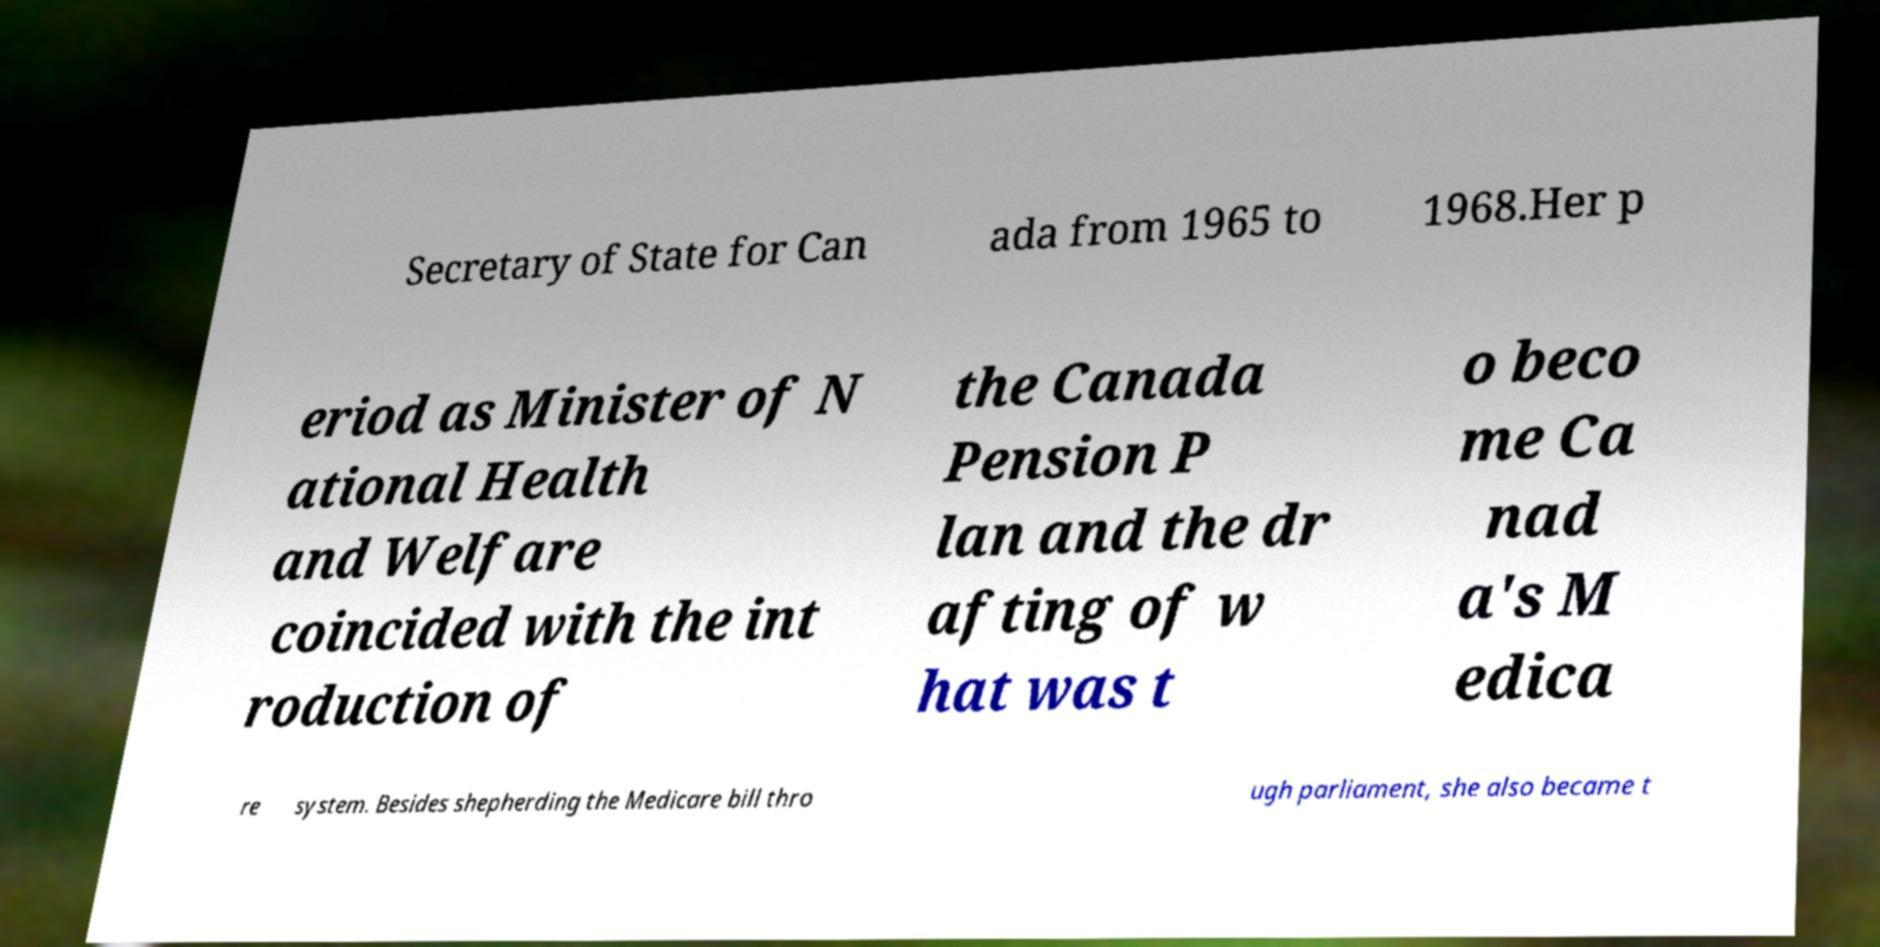What messages or text are displayed in this image? I need them in a readable, typed format. Secretary of State for Can ada from 1965 to 1968.Her p eriod as Minister of N ational Health and Welfare coincided with the int roduction of the Canada Pension P lan and the dr afting of w hat was t o beco me Ca nad a's M edica re system. Besides shepherding the Medicare bill thro ugh parliament, she also became t 